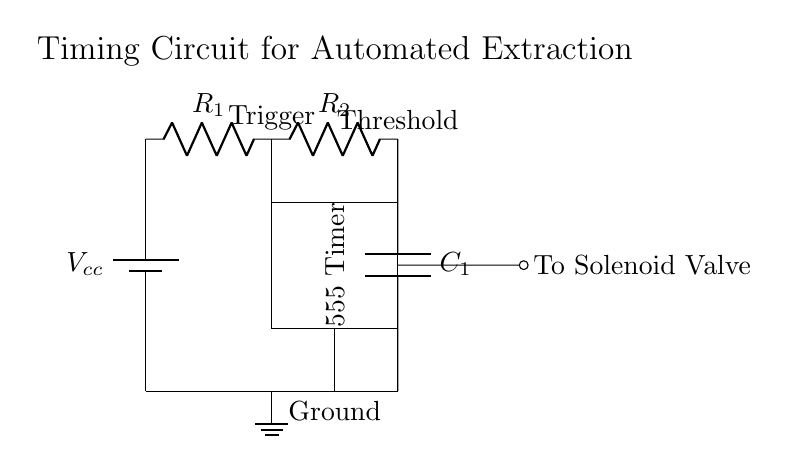What is the main component of this timing circuit? The main component is the 555 Timer, indicated in the diagram as the rectangle labeled "555 Timer". This is the primary integrated circuit used for timing applications in the circuit.
Answer: 555 Timer What are the values of the resistors shown in the circuit? The circuit diagram does not specify numerical values for resistors R1 and R2; it only shows their labels. Therefore, we cannot provide specific values for these components based on the diagram.
Answer: Not specified How many capacitors are in this circuit? There is one capacitor in the circuit as shown by the label C1, which connects between the output of resistor R2 and the ground.
Answer: One What is the function of the solenoid valve in this circuit? The solenoid valve is used to control fluid flow in the extraction process, and it is activated by the output signal from the 555 Timer, indicated by the wire going to "To Solenoid Valve".
Answer: Control fluid flow What triggers the operation of the 555 Timer in this circuit? The 555 Timer is triggered by an input signal at the "Trigger" point which is connected to resistor R1; this initiates the timing operation of the circuit.
Answer: Trigger signal What happens at the Threshold point of the 555 Timer? At the Threshold point, the voltage level is monitored; when it reaches a certain level, it resets the output to control the solenoid valve's operation, ensuring it functions correctly in timed sequences.
Answer: Resets output What type of circuit is this? This is a timing circuit designed for automation purposes, specifically for controlling solenoid valves in extraction processes, utilizing a 555 Timer for timing functions.
Answer: Timing circuit 